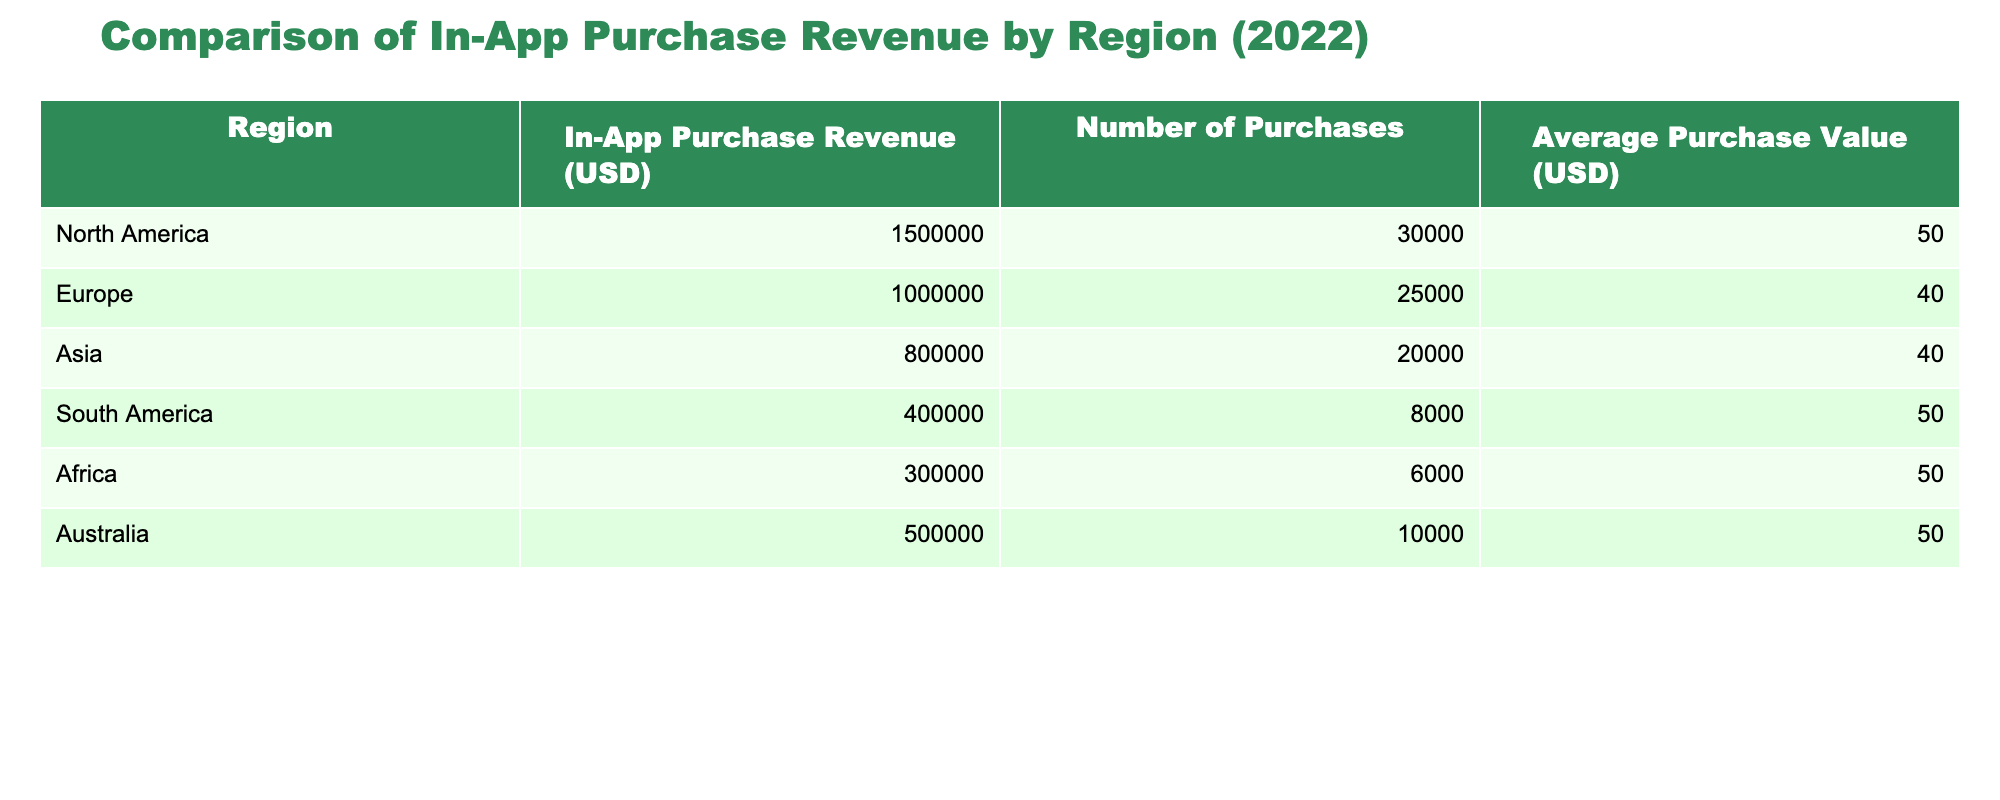What is the in-app purchase revenue for Europe? The table lists the in-app purchase revenue by region. For Europe, the value specified under the "In-App Purchase Revenue (USD)" column is 1,000,000.
Answer: 1,000,000 Which region had the highest number of purchases? The "Number of Purchases" column shows the count for each region. North America has 30,000 purchases, which is higher than any other region listed.
Answer: North America What is the average purchase value in South America? The table indicates that the average purchase value for South America, found in the "Average Purchase Value (USD)" column, is 50.
Answer: 50 Is the average purchase value in Asia higher than in Europe? The average purchase value for Asia is 40, while for Europe it is also 40. Since both are equal, the statement is false.
Answer: No What is the total in-app purchase revenue for Africa and Australia combined? The total revenue for Africa is 300,000 and for Australia is 500,000. Combining these figures gives 300,000 + 500,000 = 800,000.
Answer: 800,000 Which regions generated an average purchase value of 50? From the "Average Purchase Value (USD)" column, it can be observed that North America, South America, Africa, and Australia all have an average purchase value of 50.
Answer: North America, South America, Africa, Australia What percentage of the total in-app purchase revenue in 2022 is generated by Asia? First, calculate the total revenue: 1,500,000 + 1,000,000 + 800,000 + 400,000 + 300,000 + 500,000 = 4,500,000. Then, the percentage from Asia is (800,000 / 4,500,000) * 100 ≈ 17.78%.
Answer: Approximately 17.78% What region had the lowest revenue, and what was that revenue? By examining the "In-App Purchase Revenue (USD)" values, South America shows the lowest revenue of 400,000.
Answer: South America, 400,000 Is the number of purchases in North America twice that of Africa? North America has 30,000 purchases, and Africa has 6,000. Doubling Africa's purchases gives 12,000, which is less than North America. Thus, the statement is false.
Answer: No 